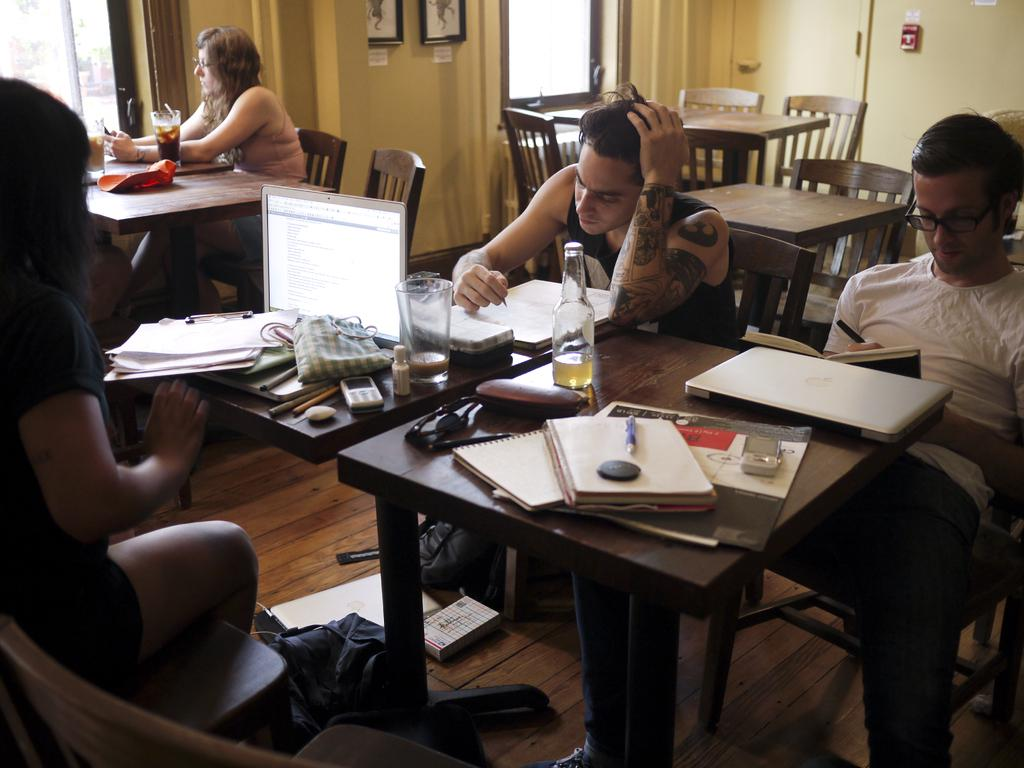How many people are in the image? There is a group of people in the image. What are the people doing in the image? The people are sitting on chairs. What is in front of the people? There is a table in front of the people. What items can be seen on the table? Books, laptops, glasses, and bottles are on the table. What is on the wall in the image? There are portraits on the wall. What type of waves can be seen crashing on the shore in the image? There are no waves or shore present in the image; it features a group of people sitting at a table with various items. 